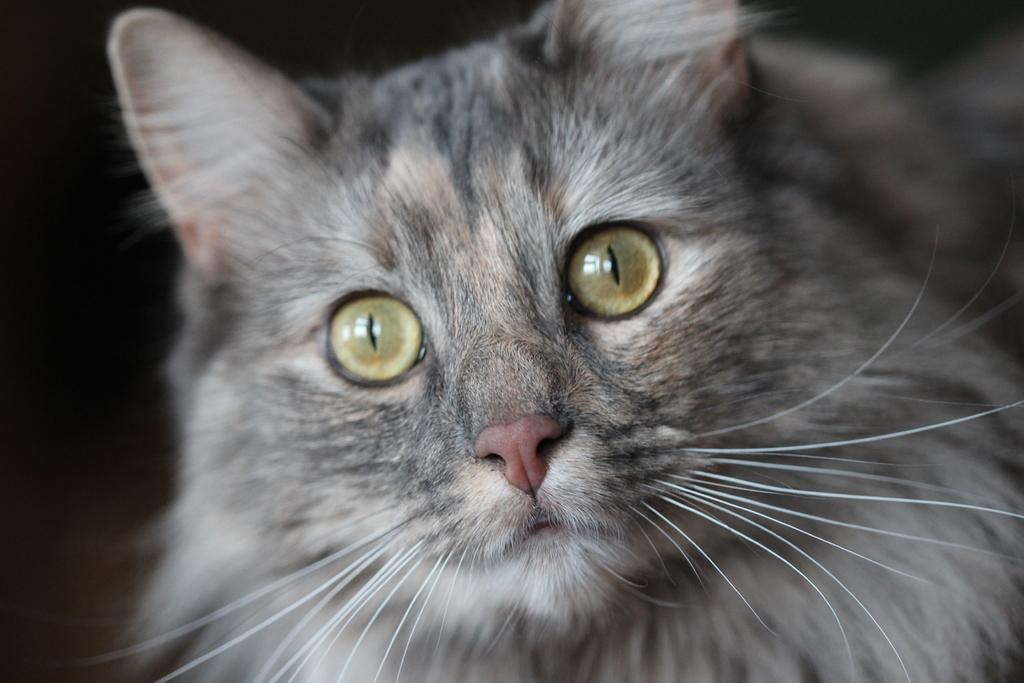Can you describe this image briefly? In the picture we can see a cat which is gray in color and some part white in color. 